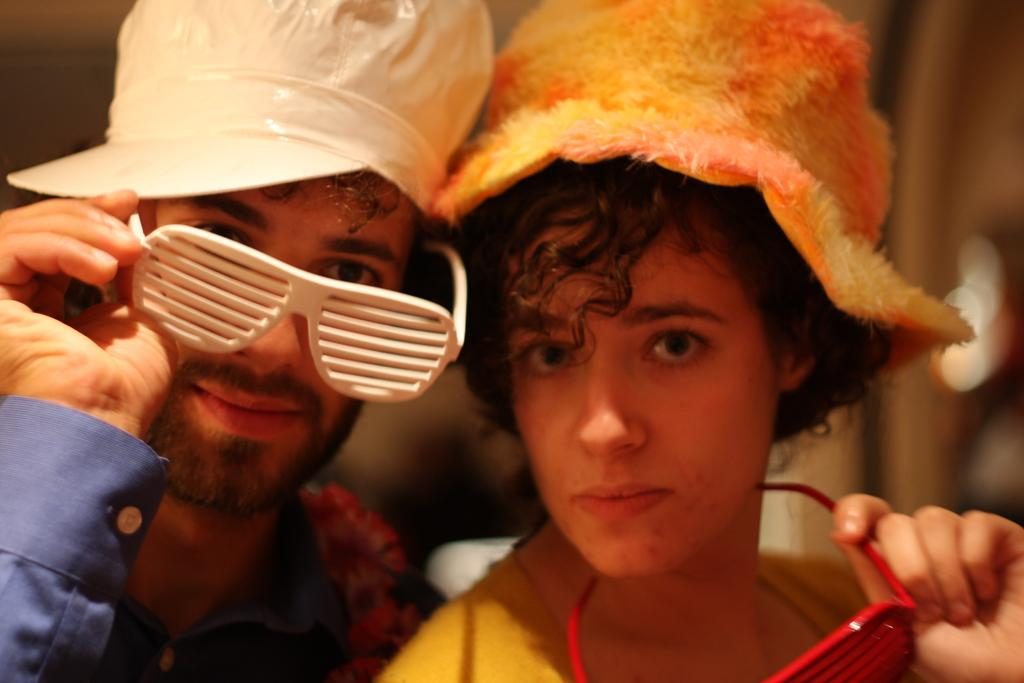How many people are in the image? There are two people in the image. What are the people doing in the image? The people are posing for a photo. What are the people wearing in the image? The people are wearing glasses. What can be observed about the background in the image? The background of the people is blurred. What type of judge is present in the image? There is no judge present in the image; it features two people posing for a photo while wearing glasses. What type of spy equipment can be seen in the image? There is no spy equipment present in the image; it features two people posing for a photo while wearing glasses. 